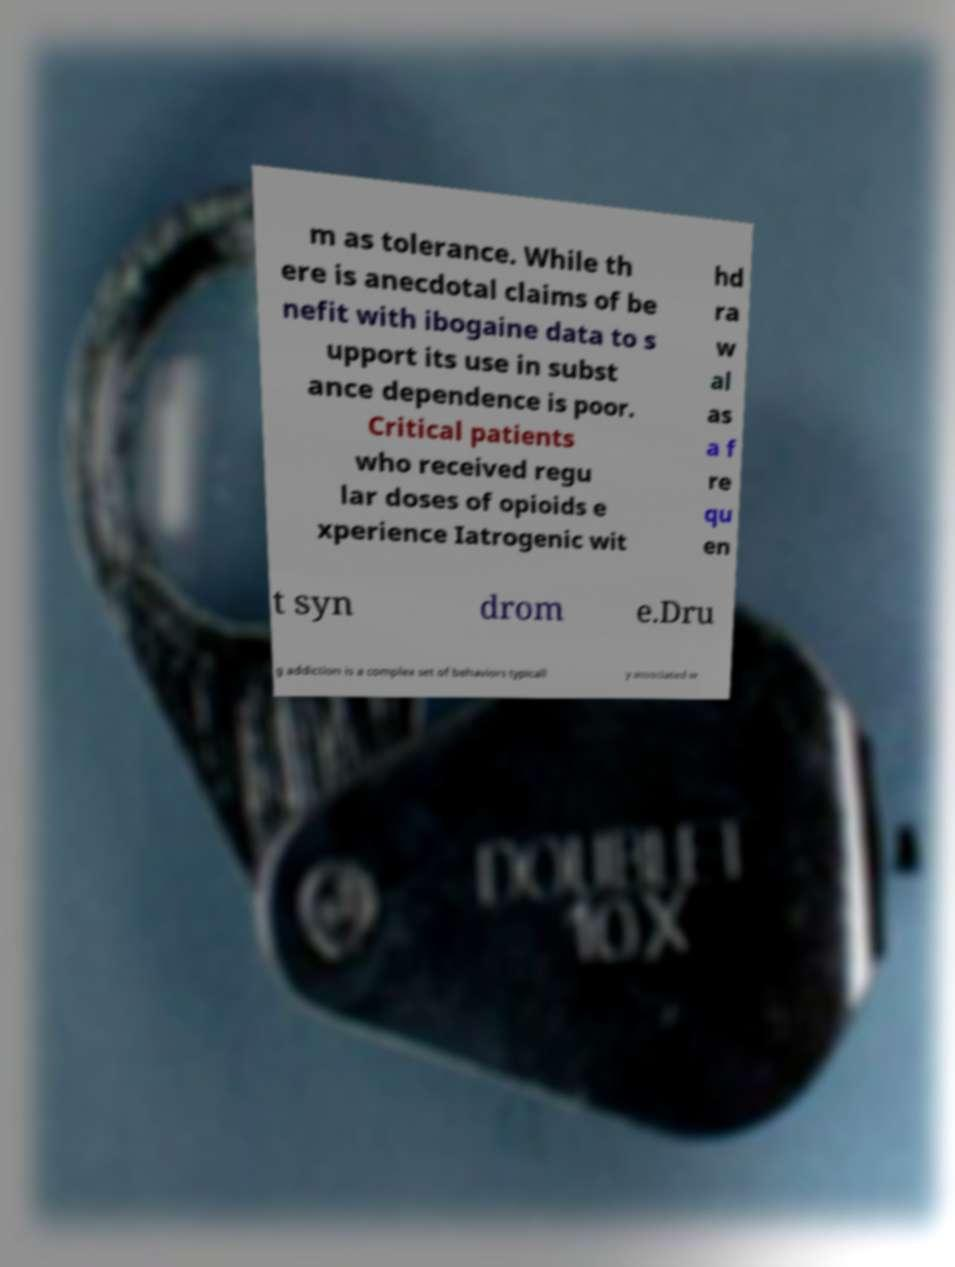For documentation purposes, I need the text within this image transcribed. Could you provide that? m as tolerance. While th ere is anecdotal claims of be nefit with ibogaine data to s upport its use in subst ance dependence is poor. Critical patients who received regu lar doses of opioids e xperience Iatrogenic wit hd ra w al as a f re qu en t syn drom e.Dru g addiction is a complex set of behaviors typicall y associated w 